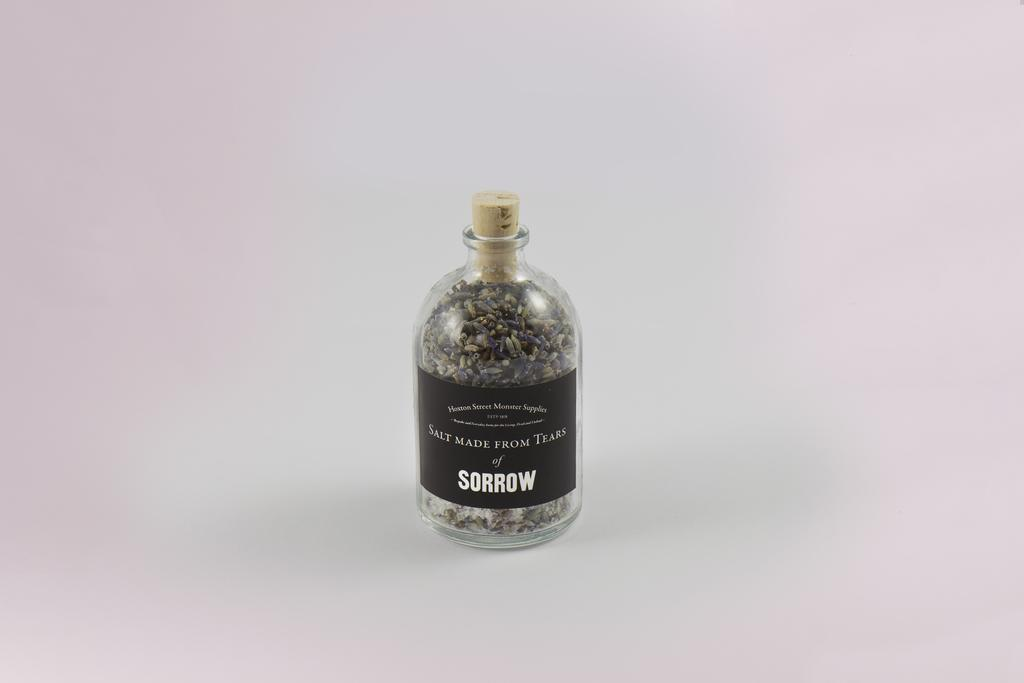<image>
Write a terse but informative summary of the picture. A glass bottle with a cork holds Salt made from Tears of Sorrow. 